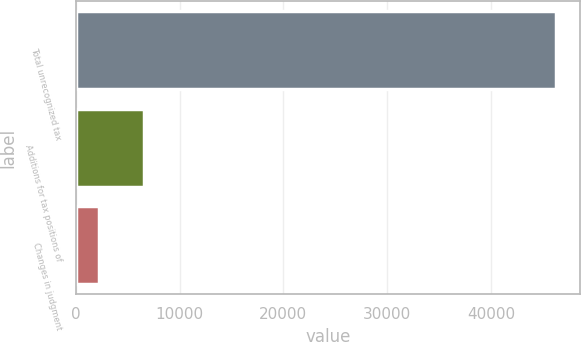Convert chart to OTSL. <chart><loc_0><loc_0><loc_500><loc_500><bar_chart><fcel>Total unrecognized tax<fcel>Additions for tax positions of<fcel>Changes in judgment<nl><fcel>46246.3<fcel>6531.3<fcel>2282<nl></chart> 